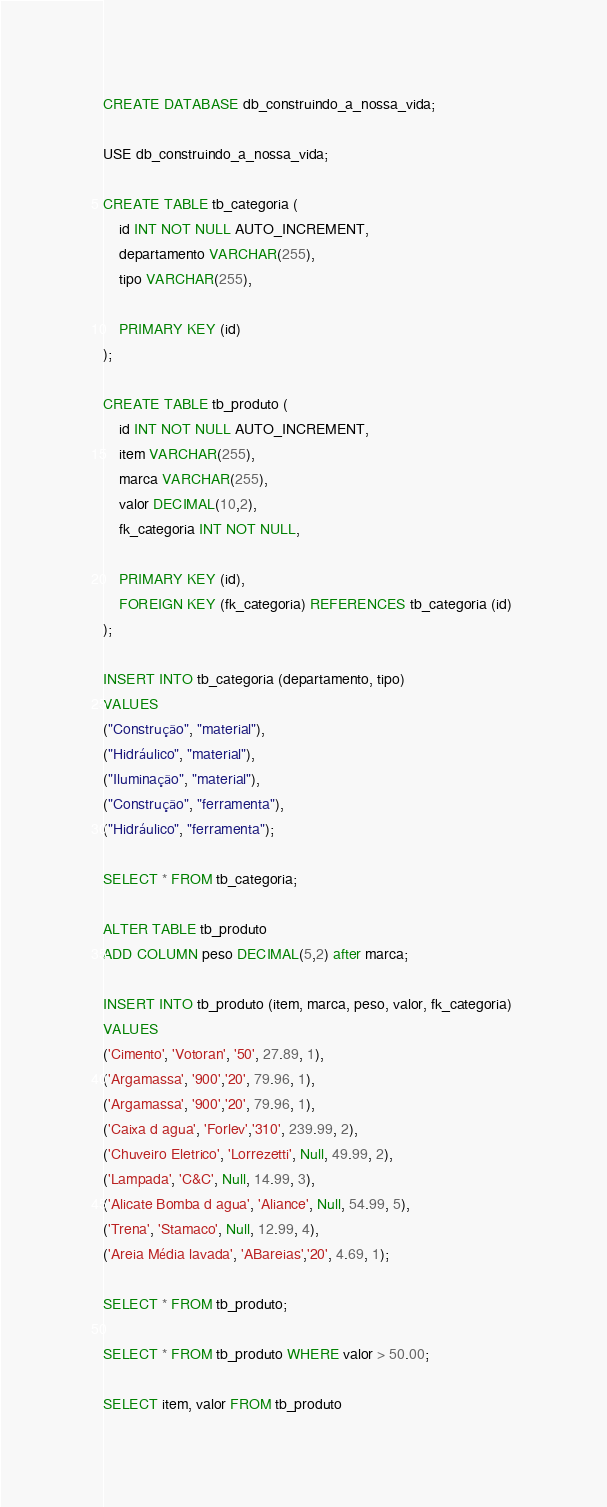Convert code to text. <code><loc_0><loc_0><loc_500><loc_500><_SQL_>CREATE DATABASE db_construindo_a_nossa_vida;

USE db_construindo_a_nossa_vida;

CREATE TABLE tb_categoria (
	id INT NOT NULL AUTO_INCREMENT,
    departamento VARCHAR(255),
    tipo VARCHAR(255),
    
    PRIMARY KEY (id)
);

CREATE TABLE tb_produto (
	id INT NOT NULL AUTO_INCREMENT,
	item VARCHAR(255),
    marca VARCHAR(255),
    valor DECIMAL(10,2),
    fk_categoria INT NOT NULL,
    
    PRIMARY KEY (id),
    FOREIGN KEY (fk_categoria) REFERENCES tb_categoria (id)
);

INSERT INTO tb_categoria (departamento, tipo) 
VALUES
("Construção", "material"),
("Hidráulico", "material"),
("Iluminação", "material"),
("Construção", "ferramenta"),
("Hidráulico", "ferramenta");

SELECT * FROM tb_categoria;

ALTER TABLE tb_produto
ADD COLUMN peso DECIMAL(5,2) after marca;

INSERT INTO tb_produto (item, marca, peso, valor, fk_categoria) 
VALUES
('Cimento', 'Votoran', '50', 27.89, 1),
('Argamassa', '900','20', 79.96, 1),
('Argamassa', '900','20', 79.96, 1),
('Caixa d agua', 'Forlev','310', 239.99, 2),
('Chuveiro Eletrico', 'Lorrezetti', Null, 49.99, 2),
('Lampada', 'C&C', Null, 14.99, 3),
('Alicate Bomba d agua', 'Aliance', Null, 54.99, 5),
('Trena', 'Stamaco', Null, 12.99, 4),
('Areia Média lavada', 'ABareias','20', 4.69, 1);

SELECT * FROM tb_produto;

SELECT * FROM tb_produto WHERE valor > 50.00;

SELECT item, valor FROM tb_produto</code> 